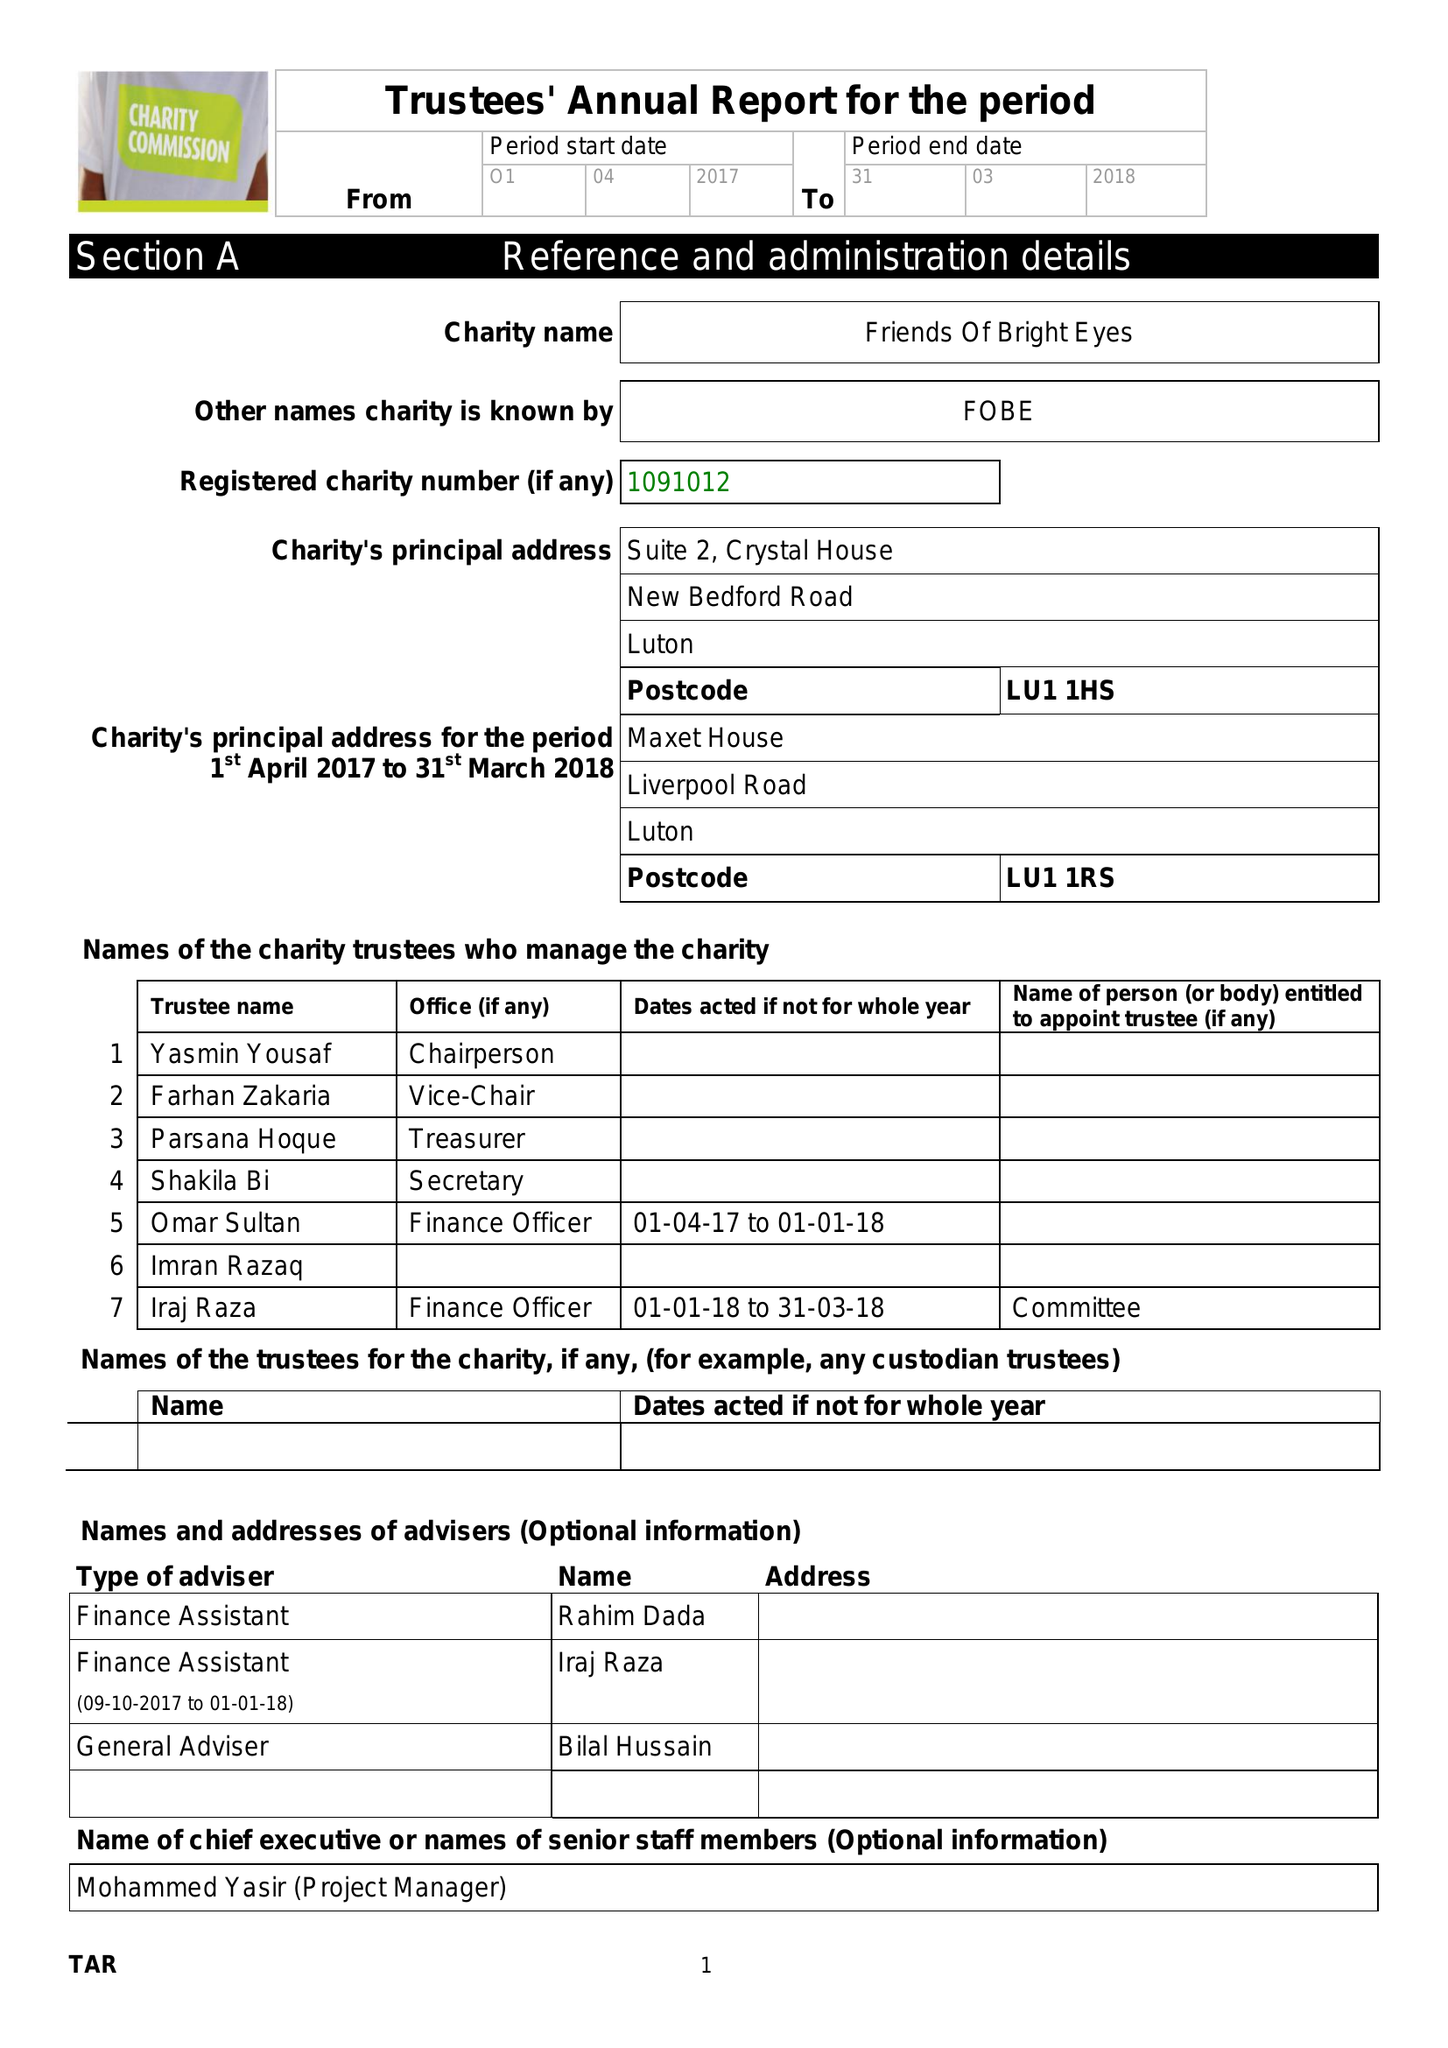What is the value for the report_date?
Answer the question using a single word or phrase. 2018-03-31 